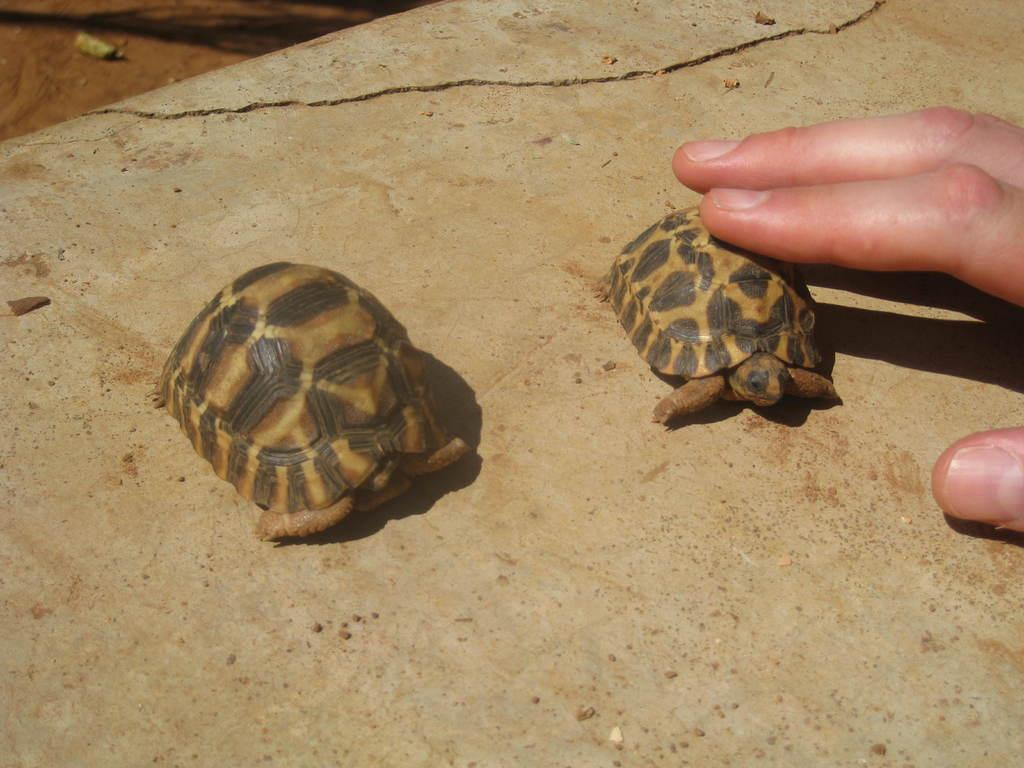How many turtles are in the picture? There are two turtles in the picture. What is the person in the picture doing with one of the turtles? The person is holding one of the turtles. What type of oranges can be seen growing in the alley near the turtles? There are no oranges or alley present in the image; it features two turtles and a person holding one of them. Can you describe the snail's shell that is crawling on the turtle's back? There is no snail present on the turtle's back in the image. 